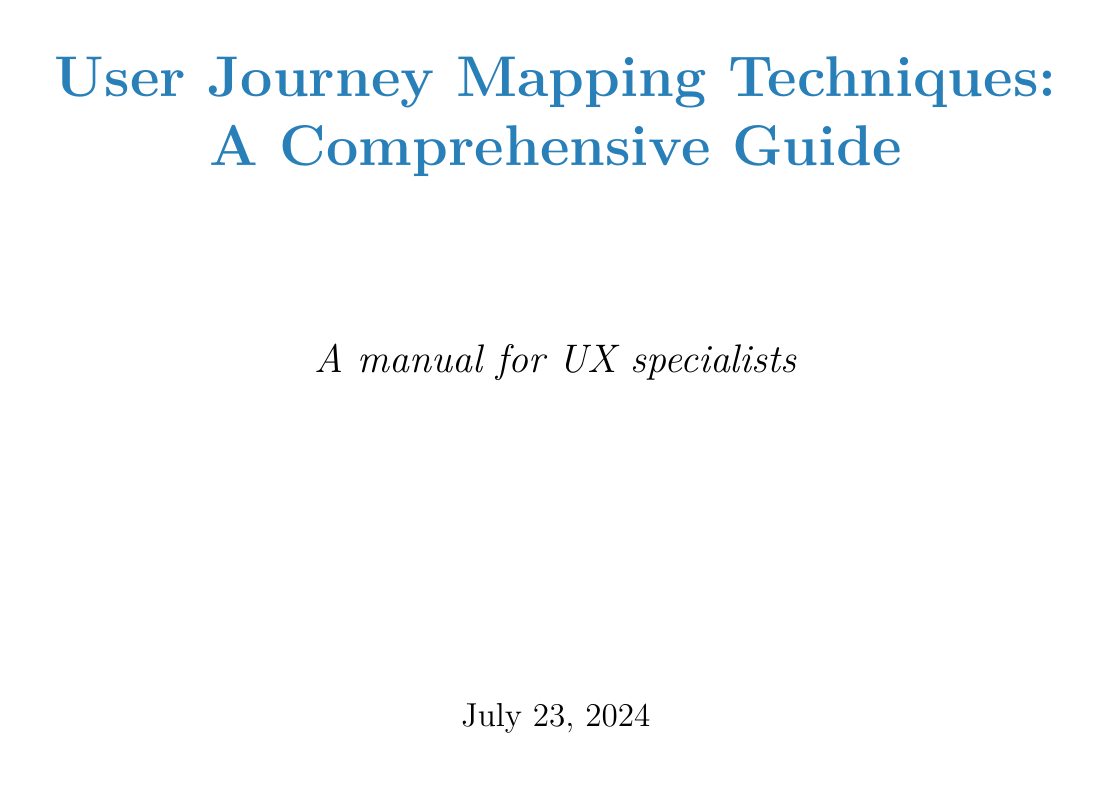what is the title of the document? The title of the document is stated at the beginning and is "User Journey Mapping Techniques: A Comprehensive Guide."
Answer: User Journey Mapping Techniques: A Comprehensive Guide who is the target audience for the guide? The target audience for the guide is mentioned as UX specialists in the manual's title page.
Answer: UX specialists how many steps are there in creating a user journey map? The number of steps is found in the "Step-by-Step Guide to Creating a User Journey Map" section, where it enumerates the steps.
Answer: Six what technique is best for planning new features? The best technique for planning new features is specified in the "User Journey Mapping Techniques" section under Future State Mapping.
Answer: Future State Mapping which tool allows for real-time collaboration? The tool that allows for real-time collaboration is mentioned in the "Tools for Creating User Journey Maps" section with a specific feature.
Answer: Miro what was one result of the mobile banking app case study? One result of the case study is displayed under the "Results" section, summarizing the changes made.
Answer: 30% reduction in time to complete common tasks what is the first step in the guide for creating a user journey map? The first step is described at the beginning of the steps list in the "Step-by-Step Guide to Creating a User Journey Map."
Answer: Define user personas how does service blueprint mapping benefit digital platforms? The benefit of service blueprint mapping for digital platforms is provided in the description of the technique.
Answer: Improving both frontend and backend aspects of digital platforms what is one of the best practices mentioned for user journey mapping? One of the best practices is included in the "Best Practices for User Journey Mapping" section.
Answer: Use real data and user research to inform your journey maps 